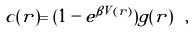Convert formula to latex. <formula><loc_0><loc_0><loc_500><loc_500>c ( r ) = ( 1 - e ^ { \beta V ( r ) } ) g ( r ) \ ,</formula> 